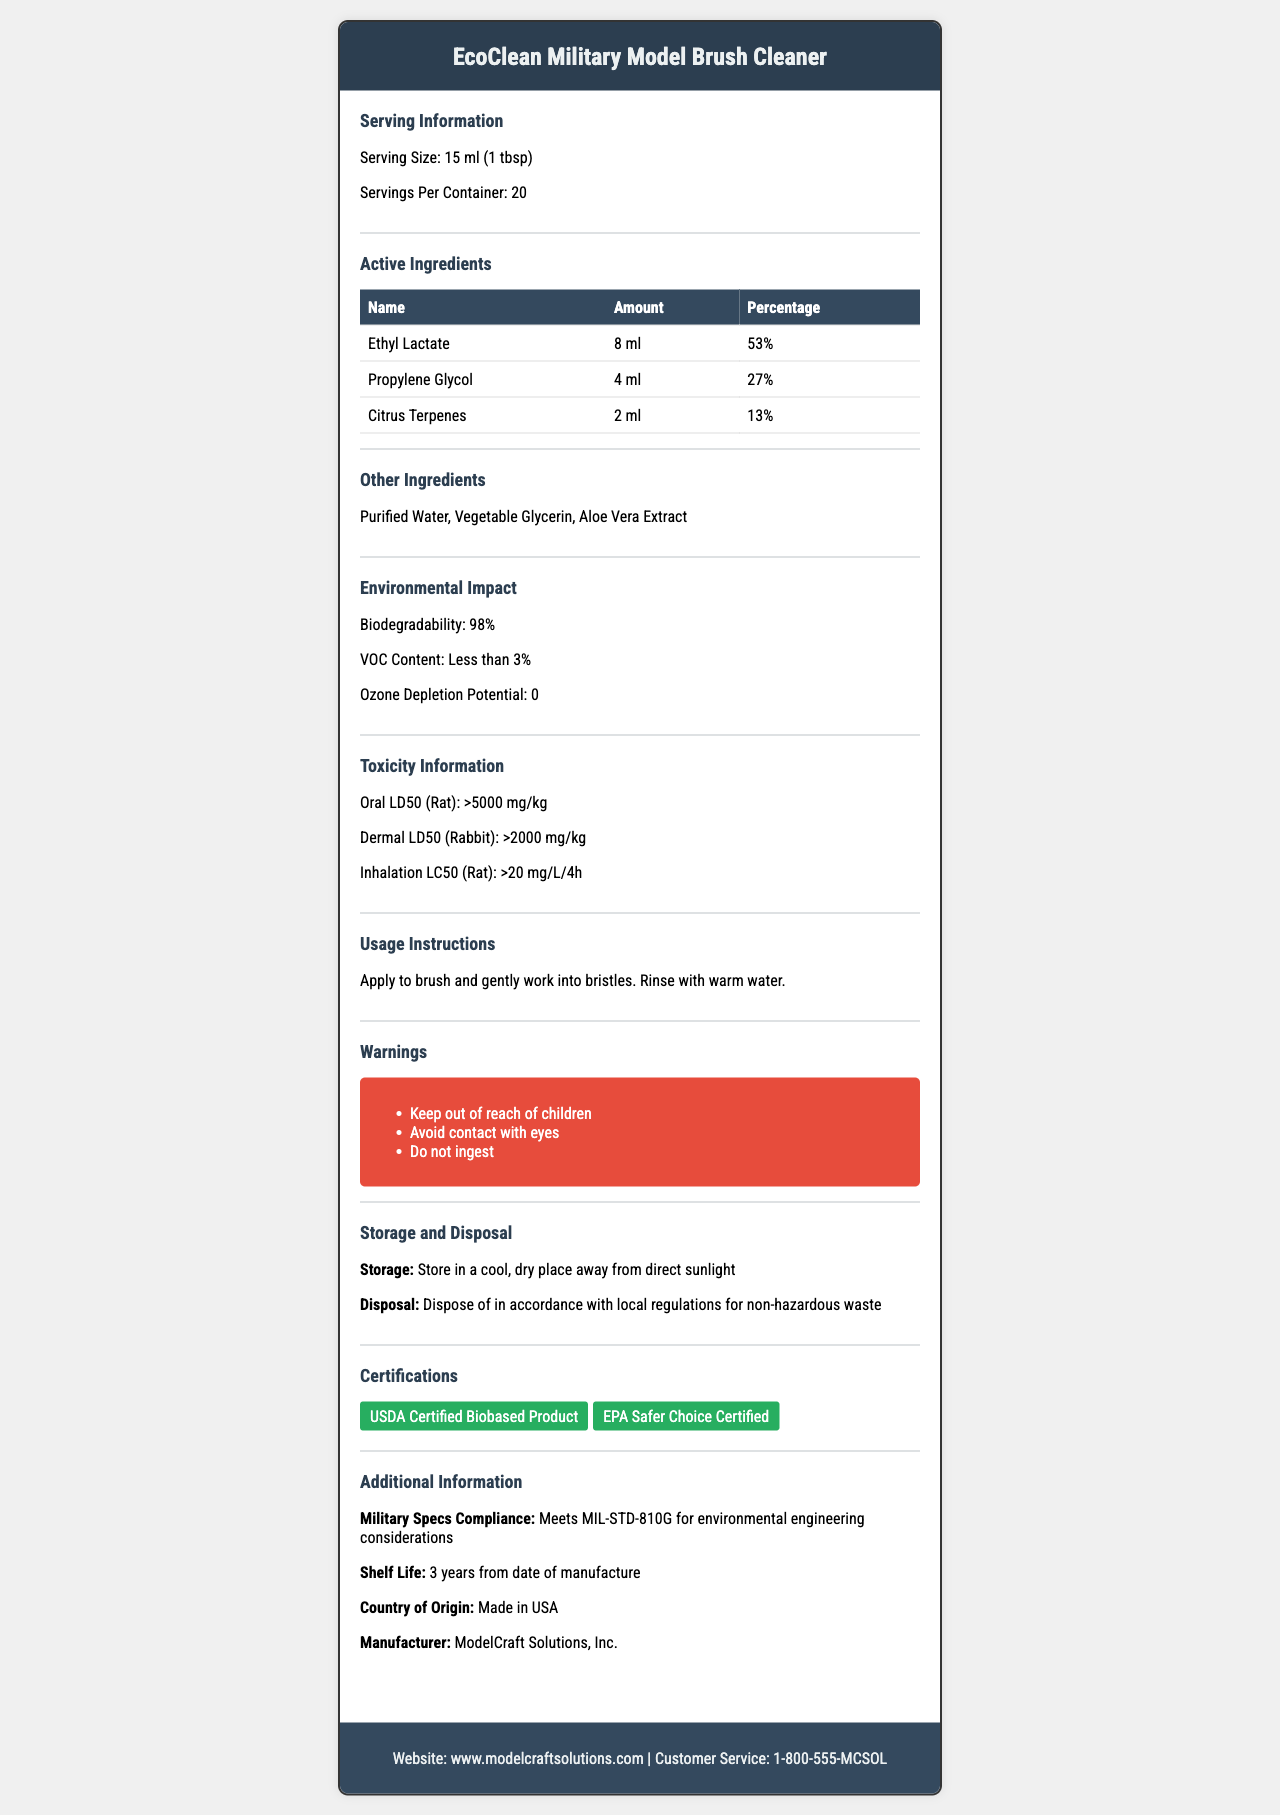what is the serving size of the EcoClean Military Model Brush Cleaner? The document specifies that the serving size is 15 ml or 1 tablespoon.
Answer: 15 ml (1 tbsp) how much Ethyl Lactate is in a single serving? According to the active ingredients section, Ethyl Lactate is 8 ml per serving.
Answer: 8 ml what is the biodegradability of the product? The environmental impact section states that the biodegradability is 98%.
Answer: 98% how should the EcoClean Military Model Brush Cleaner be stored? The storage section advises storing the product in a cool, dry place away from direct sunlight.
Answer: Store in a cool, dry place away from direct sunlight what is the shelf life of this product? The additional information section lists the shelf life as 3 years from the date of manufacture.
Answer: 3 years from date of manufacture which ingredient is present in the least amount? A. Ethyl Lactate B. Propylene Glycol C. Citrus Terpenes The active ingredients section shows Citrus Terpenes at 2 ml, which is the smallest amount among the listed ingredients.
Answer: C. Citrus Terpenes what certifications does this product have? A. USDA Certified Biobased Product B. EPA Safer Choice Certified C. Both D. None The certifications section mentions that the product is both USDA Certified Biobased Product and EPA Safer Choice Certified.
Answer: C. Both is this product safe to ingest? The warnings section clearly states "Do not ingest."
Answer: No does the product meet any military specifications? The additional information section confirms that the product meets MIL-STD-810G for environmental engineering considerations.
Answer: Yes what is the oral LD50 for rats for this product? The toxicity information section states the oral LD50 for rats is greater than 5000 mg/kg.
Answer: >5000 mg/kg explain the environmental impact of the EcoClean Military Model Brush Cleaner. These values are found in the environmental impact section, which details the product's minimal environmental footprint.
Answer: The product has a high biodegradability of 98%, a VOC content of less than 3%, and an ozone depletion potential of 0. summarize the main features and benefits of the EcoClean Military Model Brush Cleaner. The summary includes all major points: low toxicity, environmental certifications, storage instructions, and military specifications.
Answer: EcoClean Military Model Brush Cleaner is a low-toxicity, environmentally-friendly brush cleaner made with biodegradable ingredients and meeting military specifications. It has certifications from USDA and EPA, and it should be stored properly for optimal use. The product is designed to be effective while prioritizing safety and environmental health. what is the website for more information about the product? The footer of the document provides the website www.modelcraftsolutions.com for more information.
Answer: www.modelcraftsolutions.com can the exact mix ratio of the product's other ingredients be determined? The document lists Purified Water, Vegetable Glycerin, and Aloe Vera Extract in the other ingredients section, but it does not provide exact proportions or mix ratios.
Answer: No 